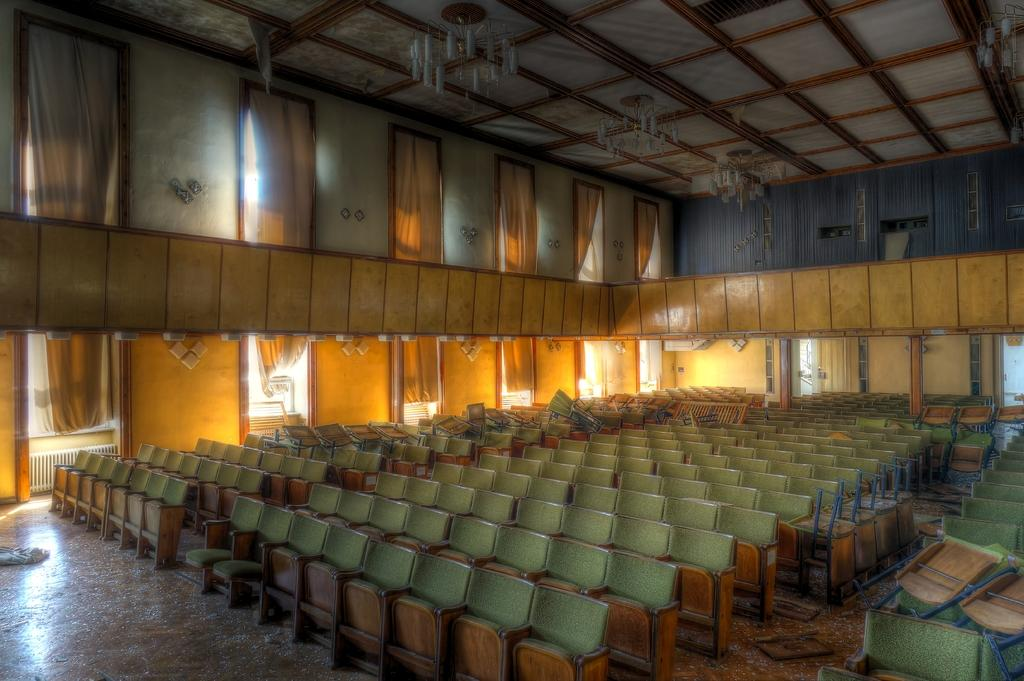What objects are placed on the path in the image? There are chairs on the path in the image. What is behind the chairs in the image? There is a wall with curtains behind the chairs in the image. What type of lighting fixture can be seen at the top of the image? There are chandeliers visible at the top of the image. What type of quiver is hanging on the wall behind the chairs in the image? There is no quiver present in the image; it features chairs on a path with a wall and curtains behind them, and chandeliers at the top. 